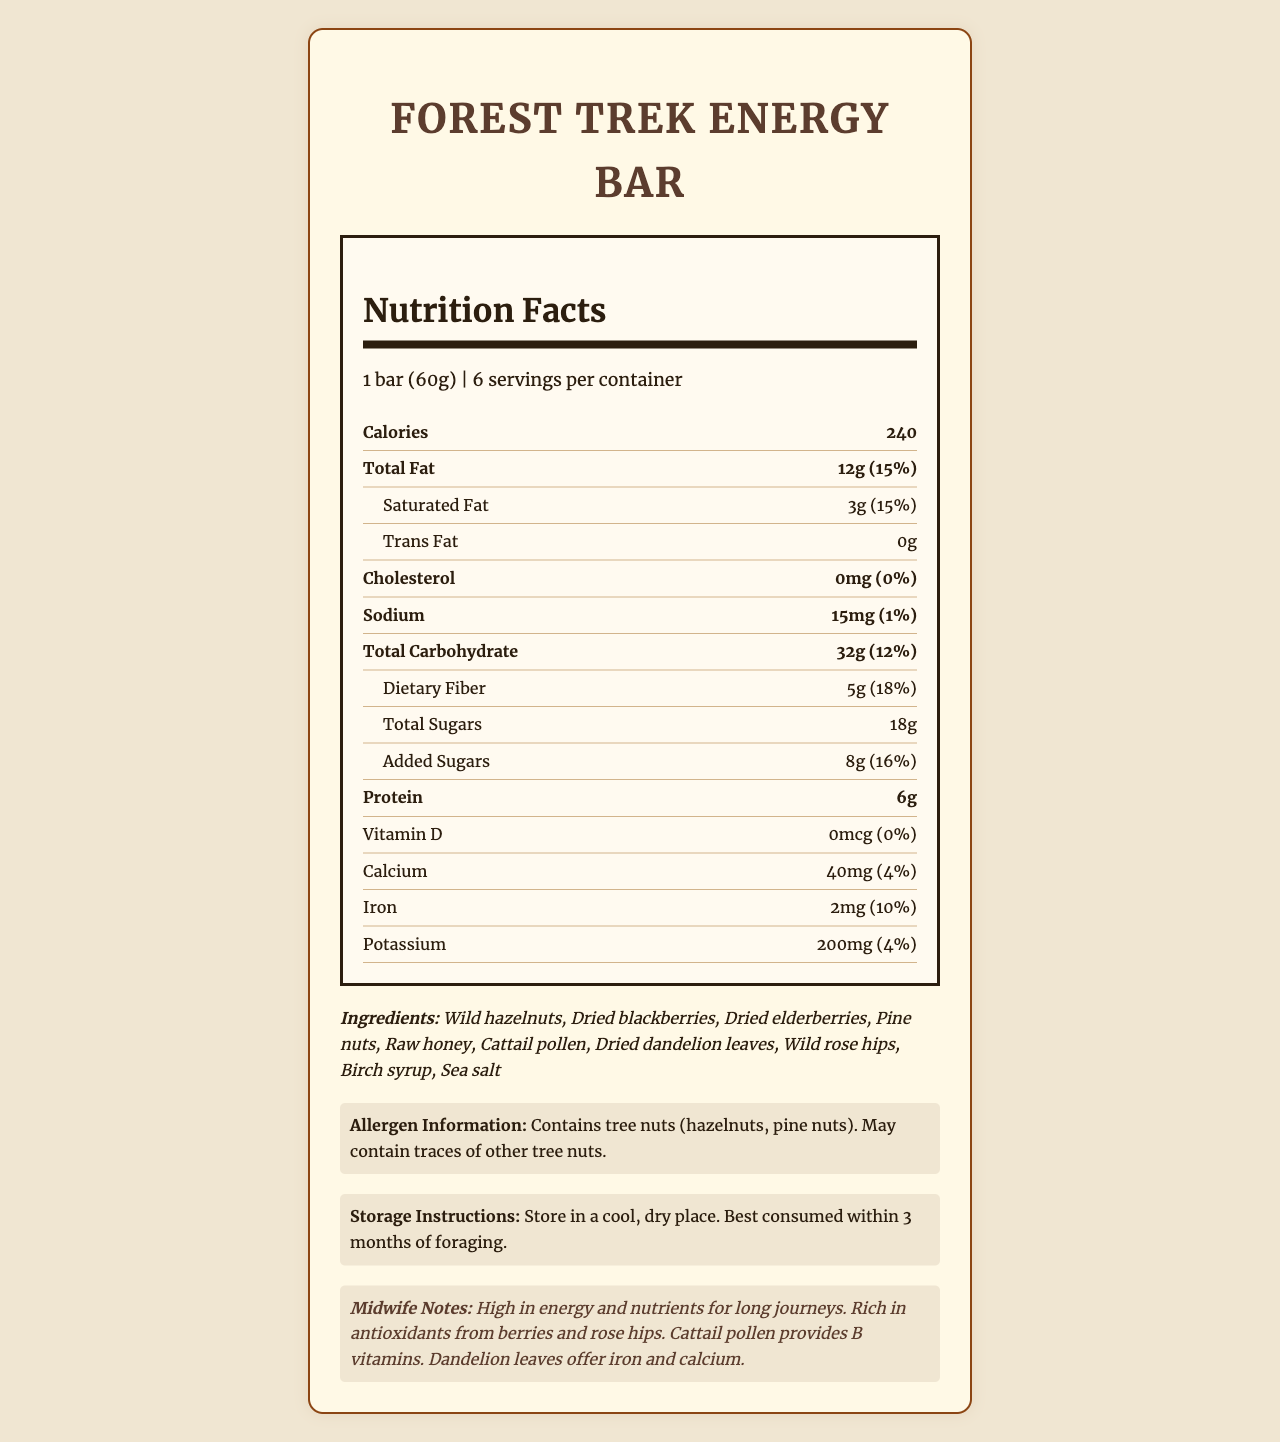what is the serving size for the Forest Trek Energy Bar? The serving size is mentioned directly in the document as "1 bar (60g)".
Answer: 1 bar (60g) how many calories are in one serving of the energy bar? The document lists the calorie content of one serving as 240 calories.
Answer: 240 which ingredients in the energy bar are foraged? The ingredients list in the document identifies all ingredients as foraged.
Answer: Wild hazelnuts, Dried blackberries, Dried elderberries, Pine nuts, Raw honey, Cattail pollen, Dried dandelion leaves, Wild rose hips, Birch syrup, Sea salt how much saturated fat does the energy bar contain in one serving? The document shows that one serving contains 3 grams of saturated fat.
Answer: 3g what is the main source of sweetness in the energy bar? The ingredients list includes raw honey and birch syrup as sources of sweetness.
Answer: Raw honey and Birch syrup what is the percentage of daily value for dietary fiber in one serving? The percentage of daily value for dietary fiber is shown as 18% in the document.
Answer: 18% how many grams of added sugars are in the energy bar? The document lists the added sugars content as 8 grams.
Answer: 8g What is the protein content of the energy bar? A. 3g B. 6g C. 9g D. 12g The document mentions that the energy bar contains 6 grams of protein per serving.
Answer: B. 6g Which of the following minerals does the energy bar contain in significant amounts? A. Sodium B. Calcium C. Iron D. Potassium While the bar contains sodium, calcium, and potassium, the iron content is most notable with a 10% daily value contribution.
Answer: C. Iron Does the energy bar contain any allergens? The document states that the bar contains tree nuts (hazelnuts, pine nuts) and may contain traces of other tree nuts.
Answer: Yes Summarize the main idea of the document. The document provides detailed nutritional information about the Forest Trek Energy Bar, emphasizing its energy content and health benefits from natural, foraged ingredients, and contains notes specifically for midwives on long journeys.
Answer: The document is a Nutrition Facts label for Forest Trek Energy Bar, highlighting its health benefits and nutritional content including a significant amount of energy, fats, carbohydrates, and proteins, derived from foraged ingredients. It also specifies allergy information and storage instructions. How many grams of trans fat are in the energy bar? The document clearly lists the trans fat content as 0 grams.
Answer: 0g what is the manufacturing date of the energy bar? The document does not provide any information regarding the manufacturing date of the energy bar.
Answer: Cannot be determined 